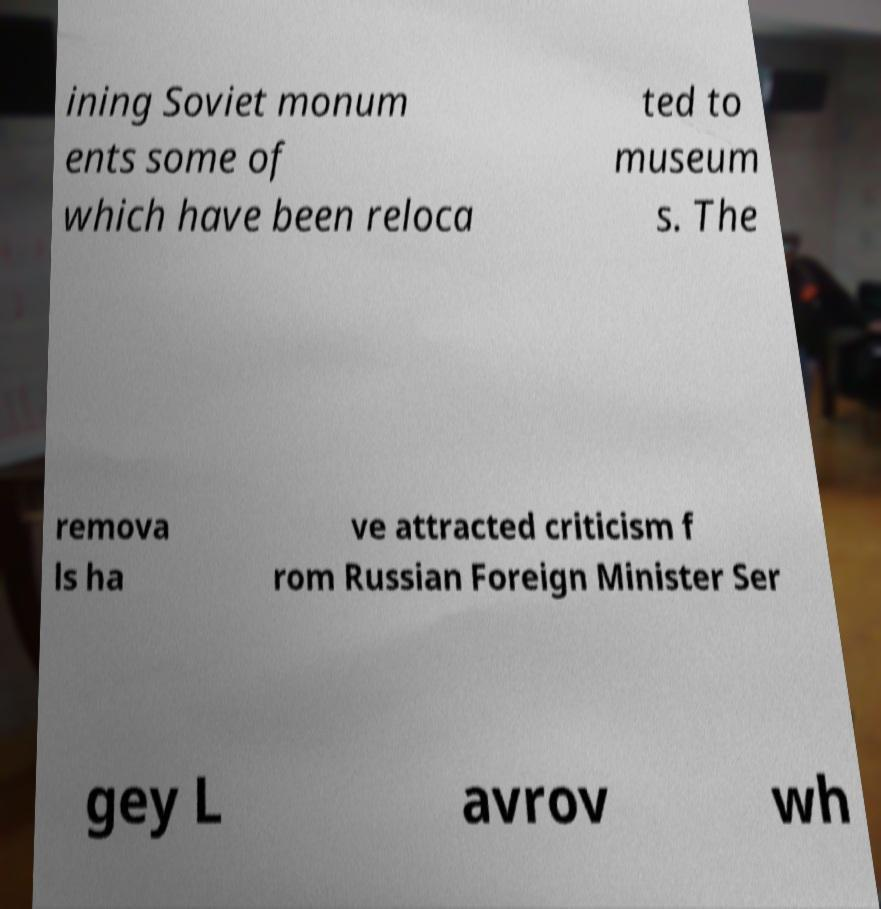Could you assist in decoding the text presented in this image and type it out clearly? ining Soviet monum ents some of which have been reloca ted to museum s. The remova ls ha ve attracted criticism f rom Russian Foreign Minister Ser gey L avrov wh 